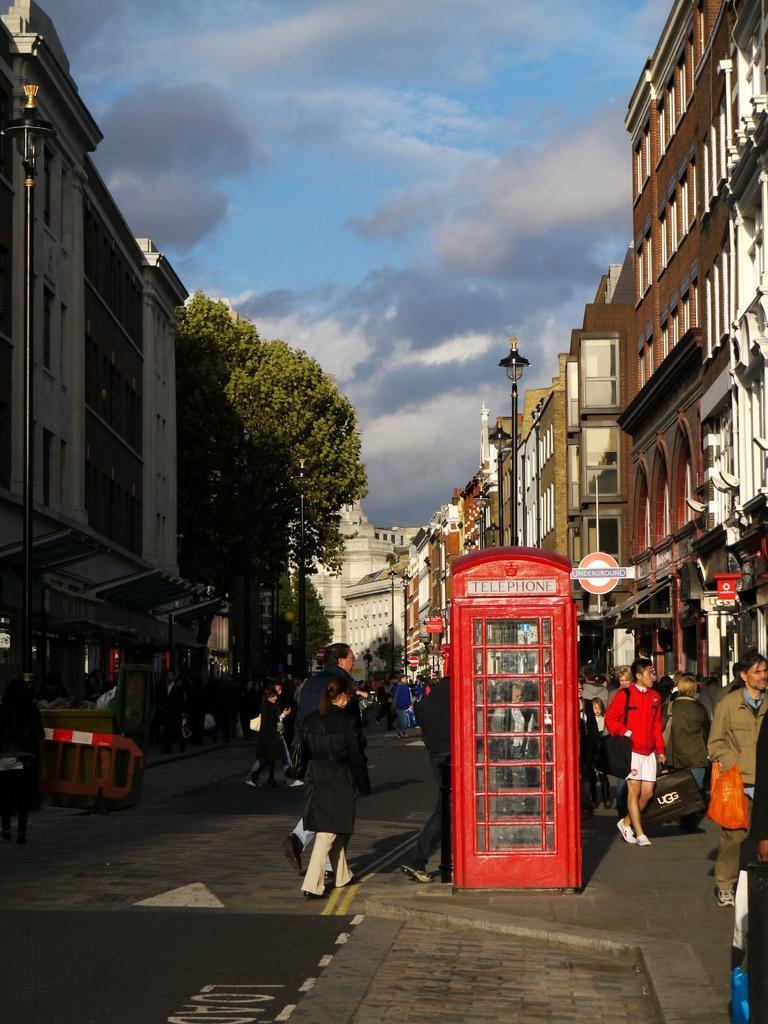Describe this image in one or two sentences. In the foreground of this image, there is road, few people walking on the side path and few are walking on the road and also there is a telephone booth, few trees on the left and the sky at the top. On either side to the road, there are poles and the buildings. 